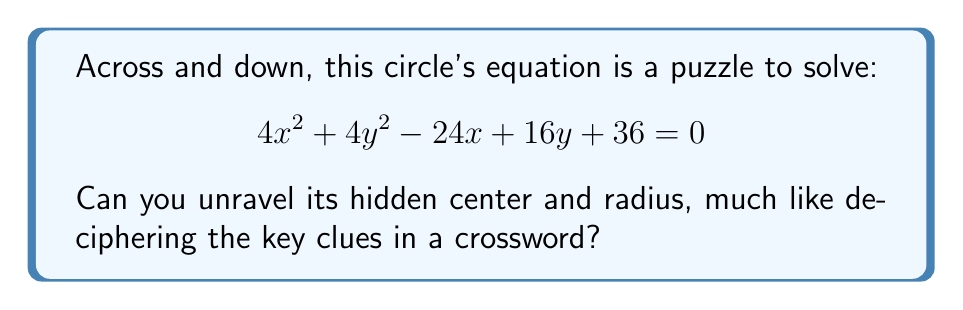Help me with this question. Let's approach this step-by-step, similar to solving a crossword puzzle:

1) First, we need to recognize the general form of a circle equation:
   $$ (x - h)^2 + (y - k)^2 = r^2 $$
   where $(h,k)$ is the center and $r$ is the radius.

2) Our equation is in the form:
   $$ 4x^2 + 4y^2 - 24x + 16y + 36 = 0 $$

3) To match the general form, we need to group $x$ terms and $y$ terms:
   $$ (4x^2 - 24x) + (4y^2 + 16y) = -36 $$

4) Factor out the coefficients of $x^2$ and $y^2$:
   $$ 4(x^2 - 6x) + 4(y^2 + 4y) = -36 $$

5) Complete the square for both $x$ and $y$ terms:
   $$ 4(x^2 - 6x + 9 - 9) + 4(y^2 + 4y + 4 - 4) = -36 $$
   $$ 4[(x - 3)^2 - 9] + 4[(y + 2)^2 - 4] = -36 $$

6) Simplify:
   $$ 4(x - 3)^2 + 4(y + 2)^2 = 4(9) + 4(4) - 36 $$
   $$ 4(x - 3)^2 + 4(y + 2)^2 = 16 $$

7) Divide both sides by 4:
   $$ (x - 3)^2 + (y + 2)^2 = 4 $$

Now we have the equation in the standard form $(x - h)^2 + (y - k)^2 = r^2$.
Answer: Center: $(3, -2)$
Radius: $2$ 